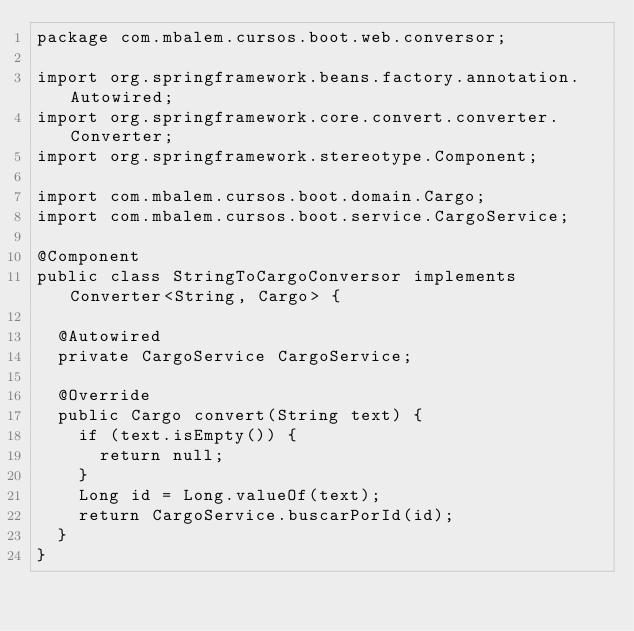Convert code to text. <code><loc_0><loc_0><loc_500><loc_500><_Java_>package com.mbalem.cursos.boot.web.conversor;

import org.springframework.beans.factory.annotation.Autowired;
import org.springframework.core.convert.converter.Converter;
import org.springframework.stereotype.Component;

import com.mbalem.cursos.boot.domain.Cargo;
import com.mbalem.cursos.boot.service.CargoService;

@Component
public class StringToCargoConversor implements Converter<String, Cargo> {

	@Autowired
	private CargoService CargoService;
	
	@Override
	public Cargo convert(String text) {
		if (text.isEmpty()) {
			return null;
		}
		Long id = Long.valueOf(text);
		return CargoService.buscarPorId(id);
	}
}
</code> 